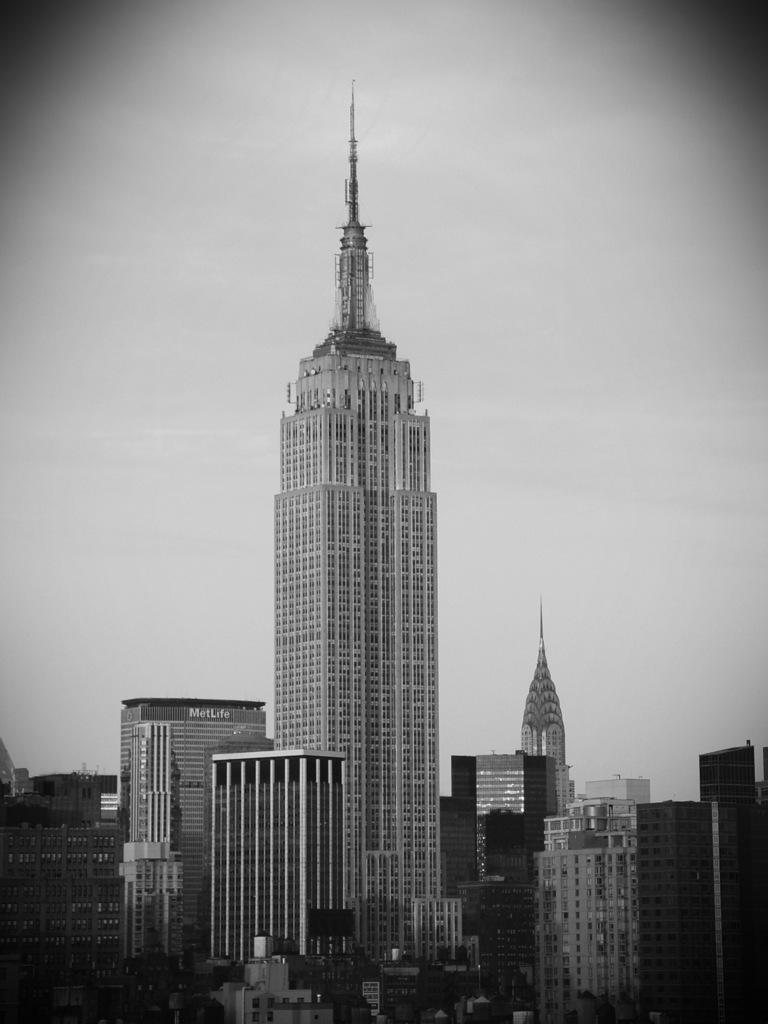What type of structures can be seen in the image? There are buildings in the image. What part of the natural environment is visible in the image? The sky is visible in the image. What type of instrument is being played by the mice in the image? There are no mice or instruments present in the image. Can you see any bones in the image? There are no bones visible in the image. 